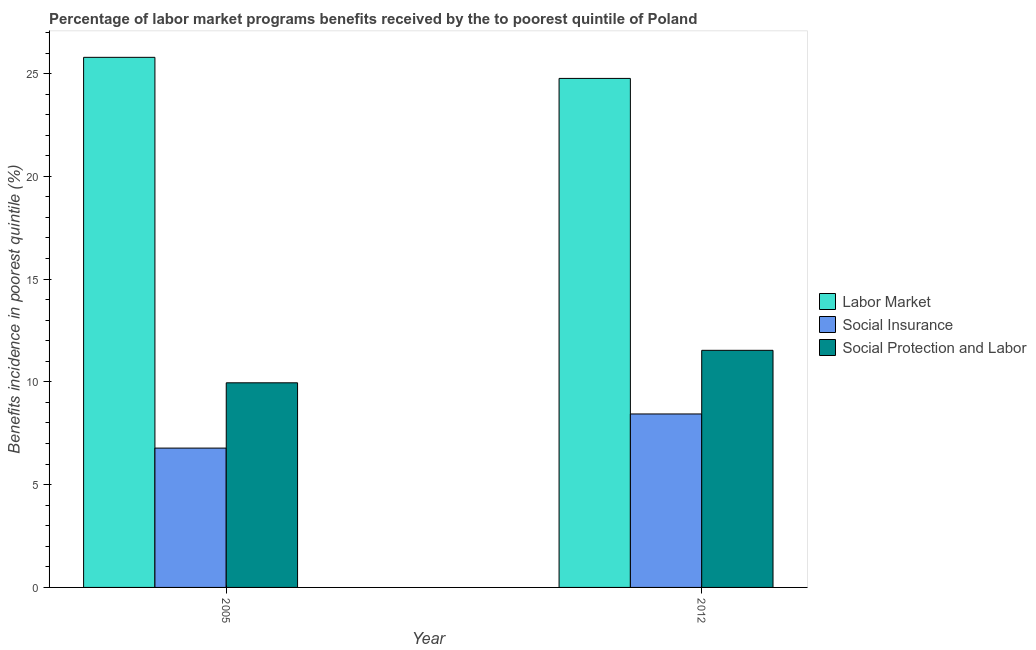How many groups of bars are there?
Your response must be concise. 2. Are the number of bars per tick equal to the number of legend labels?
Ensure brevity in your answer.  Yes. What is the label of the 1st group of bars from the left?
Offer a terse response. 2005. What is the percentage of benefits received due to labor market programs in 2005?
Your answer should be compact. 25.79. Across all years, what is the maximum percentage of benefits received due to labor market programs?
Offer a terse response. 25.79. Across all years, what is the minimum percentage of benefits received due to social protection programs?
Give a very brief answer. 9.96. In which year was the percentage of benefits received due to social insurance programs maximum?
Provide a succinct answer. 2012. What is the total percentage of benefits received due to social insurance programs in the graph?
Keep it short and to the point. 15.22. What is the difference between the percentage of benefits received due to labor market programs in 2005 and that in 2012?
Keep it short and to the point. 1.03. What is the difference between the percentage of benefits received due to social protection programs in 2012 and the percentage of benefits received due to labor market programs in 2005?
Your response must be concise. 1.58. What is the average percentage of benefits received due to labor market programs per year?
Give a very brief answer. 25.28. What is the ratio of the percentage of benefits received due to labor market programs in 2005 to that in 2012?
Keep it short and to the point. 1.04. What does the 1st bar from the left in 2012 represents?
Offer a terse response. Labor Market. What does the 1st bar from the right in 2012 represents?
Your answer should be compact. Social Protection and Labor. Are all the bars in the graph horizontal?
Your response must be concise. No. Are the values on the major ticks of Y-axis written in scientific E-notation?
Provide a succinct answer. No. Does the graph contain any zero values?
Make the answer very short. No. Does the graph contain grids?
Make the answer very short. No. Where does the legend appear in the graph?
Offer a terse response. Center right. How many legend labels are there?
Your answer should be compact. 3. How are the legend labels stacked?
Provide a short and direct response. Vertical. What is the title of the graph?
Provide a short and direct response. Percentage of labor market programs benefits received by the to poorest quintile of Poland. What is the label or title of the Y-axis?
Ensure brevity in your answer.  Benefits incidence in poorest quintile (%). What is the Benefits incidence in poorest quintile (%) in Labor Market in 2005?
Your answer should be very brief. 25.79. What is the Benefits incidence in poorest quintile (%) of Social Insurance in 2005?
Give a very brief answer. 6.78. What is the Benefits incidence in poorest quintile (%) of Social Protection and Labor in 2005?
Make the answer very short. 9.96. What is the Benefits incidence in poorest quintile (%) in Labor Market in 2012?
Provide a short and direct response. 24.76. What is the Benefits incidence in poorest quintile (%) of Social Insurance in 2012?
Offer a terse response. 8.44. What is the Benefits incidence in poorest quintile (%) of Social Protection and Labor in 2012?
Your answer should be compact. 11.54. Across all years, what is the maximum Benefits incidence in poorest quintile (%) in Labor Market?
Ensure brevity in your answer.  25.79. Across all years, what is the maximum Benefits incidence in poorest quintile (%) in Social Insurance?
Provide a succinct answer. 8.44. Across all years, what is the maximum Benefits incidence in poorest quintile (%) in Social Protection and Labor?
Keep it short and to the point. 11.54. Across all years, what is the minimum Benefits incidence in poorest quintile (%) of Labor Market?
Keep it short and to the point. 24.76. Across all years, what is the minimum Benefits incidence in poorest quintile (%) in Social Insurance?
Give a very brief answer. 6.78. Across all years, what is the minimum Benefits incidence in poorest quintile (%) of Social Protection and Labor?
Offer a terse response. 9.96. What is the total Benefits incidence in poorest quintile (%) of Labor Market in the graph?
Give a very brief answer. 50.55. What is the total Benefits incidence in poorest quintile (%) in Social Insurance in the graph?
Provide a succinct answer. 15.22. What is the total Benefits incidence in poorest quintile (%) in Social Protection and Labor in the graph?
Give a very brief answer. 21.49. What is the difference between the Benefits incidence in poorest quintile (%) of Labor Market in 2005 and that in 2012?
Your answer should be very brief. 1.03. What is the difference between the Benefits incidence in poorest quintile (%) in Social Insurance in 2005 and that in 2012?
Your response must be concise. -1.66. What is the difference between the Benefits incidence in poorest quintile (%) in Social Protection and Labor in 2005 and that in 2012?
Offer a terse response. -1.58. What is the difference between the Benefits incidence in poorest quintile (%) in Labor Market in 2005 and the Benefits incidence in poorest quintile (%) in Social Insurance in 2012?
Keep it short and to the point. 17.35. What is the difference between the Benefits incidence in poorest quintile (%) in Labor Market in 2005 and the Benefits incidence in poorest quintile (%) in Social Protection and Labor in 2012?
Provide a succinct answer. 14.25. What is the difference between the Benefits incidence in poorest quintile (%) in Social Insurance in 2005 and the Benefits incidence in poorest quintile (%) in Social Protection and Labor in 2012?
Give a very brief answer. -4.76. What is the average Benefits incidence in poorest quintile (%) of Labor Market per year?
Offer a very short reply. 25.28. What is the average Benefits incidence in poorest quintile (%) of Social Insurance per year?
Ensure brevity in your answer.  7.61. What is the average Benefits incidence in poorest quintile (%) of Social Protection and Labor per year?
Keep it short and to the point. 10.75. In the year 2005, what is the difference between the Benefits incidence in poorest quintile (%) in Labor Market and Benefits incidence in poorest quintile (%) in Social Insurance?
Ensure brevity in your answer.  19.01. In the year 2005, what is the difference between the Benefits incidence in poorest quintile (%) in Labor Market and Benefits incidence in poorest quintile (%) in Social Protection and Labor?
Provide a short and direct response. 15.83. In the year 2005, what is the difference between the Benefits incidence in poorest quintile (%) of Social Insurance and Benefits incidence in poorest quintile (%) of Social Protection and Labor?
Provide a succinct answer. -3.18. In the year 2012, what is the difference between the Benefits incidence in poorest quintile (%) of Labor Market and Benefits incidence in poorest quintile (%) of Social Insurance?
Provide a succinct answer. 16.32. In the year 2012, what is the difference between the Benefits incidence in poorest quintile (%) in Labor Market and Benefits incidence in poorest quintile (%) in Social Protection and Labor?
Ensure brevity in your answer.  13.23. In the year 2012, what is the difference between the Benefits incidence in poorest quintile (%) of Social Insurance and Benefits incidence in poorest quintile (%) of Social Protection and Labor?
Keep it short and to the point. -3.1. What is the ratio of the Benefits incidence in poorest quintile (%) in Labor Market in 2005 to that in 2012?
Offer a very short reply. 1.04. What is the ratio of the Benefits incidence in poorest quintile (%) of Social Insurance in 2005 to that in 2012?
Ensure brevity in your answer.  0.8. What is the ratio of the Benefits incidence in poorest quintile (%) of Social Protection and Labor in 2005 to that in 2012?
Ensure brevity in your answer.  0.86. What is the difference between the highest and the second highest Benefits incidence in poorest quintile (%) in Labor Market?
Provide a succinct answer. 1.03. What is the difference between the highest and the second highest Benefits incidence in poorest quintile (%) of Social Insurance?
Your answer should be very brief. 1.66. What is the difference between the highest and the second highest Benefits incidence in poorest quintile (%) in Social Protection and Labor?
Offer a terse response. 1.58. What is the difference between the highest and the lowest Benefits incidence in poorest quintile (%) in Labor Market?
Keep it short and to the point. 1.03. What is the difference between the highest and the lowest Benefits incidence in poorest quintile (%) of Social Insurance?
Your answer should be compact. 1.66. What is the difference between the highest and the lowest Benefits incidence in poorest quintile (%) in Social Protection and Labor?
Provide a short and direct response. 1.58. 